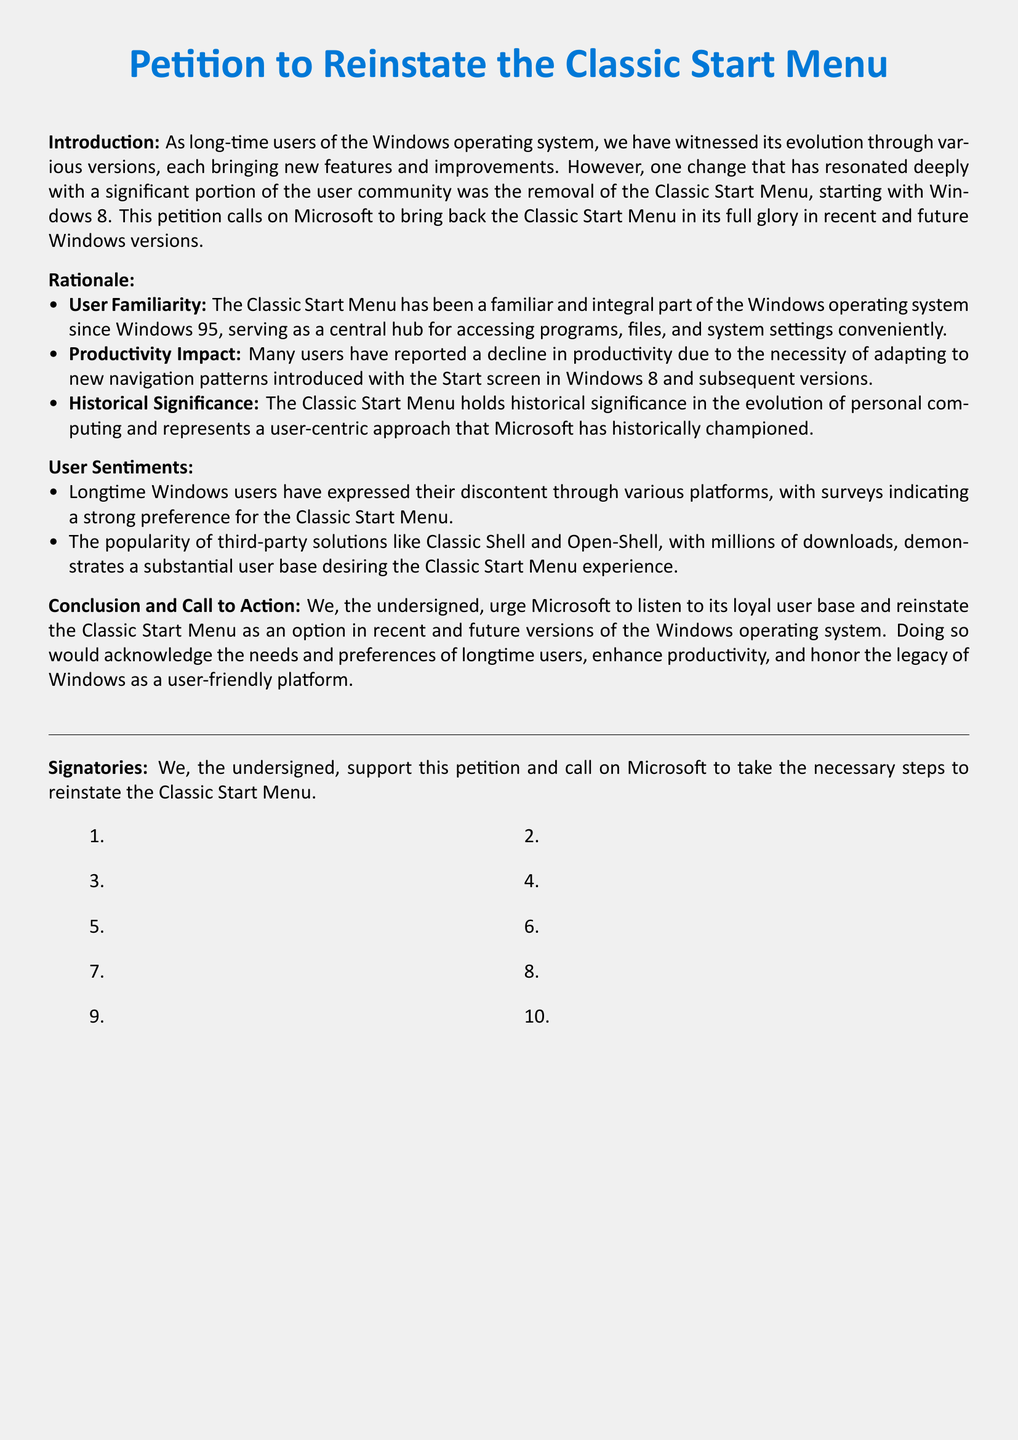What is the title of the petition? The title is explicitly stated at the beginning of the document.
Answer: Petition to Reinstate the Classic Start Menu Who is the petition directed to? The document specifies that the petition is addressed to Microsoft.
Answer: Microsoft What feature was removed in Windows 8? The document discusses the specific feature that was removed starting with Windows 8.
Answer: Classic Start Menu How long has the Classic Start Menu been part of Windows? The document indicates the year when the Classic Start Menu was introduced.
Answer: Since Windows 95 What is one reason cited for the productivity impact? The document lists a reason why users feel their productivity has declined.
Answer: Necessity of adapting to new navigation patterns How have users expressed their dissatisfaction? The document mentions how users have communicated their preference for the Classic Start Menu.
Answer: Through various platforms What percentage of downloads for third-party solutions indicates user demand? The document emphasizes the popularity of third-party solutions, which suggest a substantial user base.
Answer: Millions of downloads What is the main call to action? The petition concludes with an explicit call to action for Microsoft.
Answer: Reinstate the Classic Start Menu How do users feel about the Classic Start Menu? The document summarizes user sentiments regarding the Classic Start Menu.
Answer: Discontent 